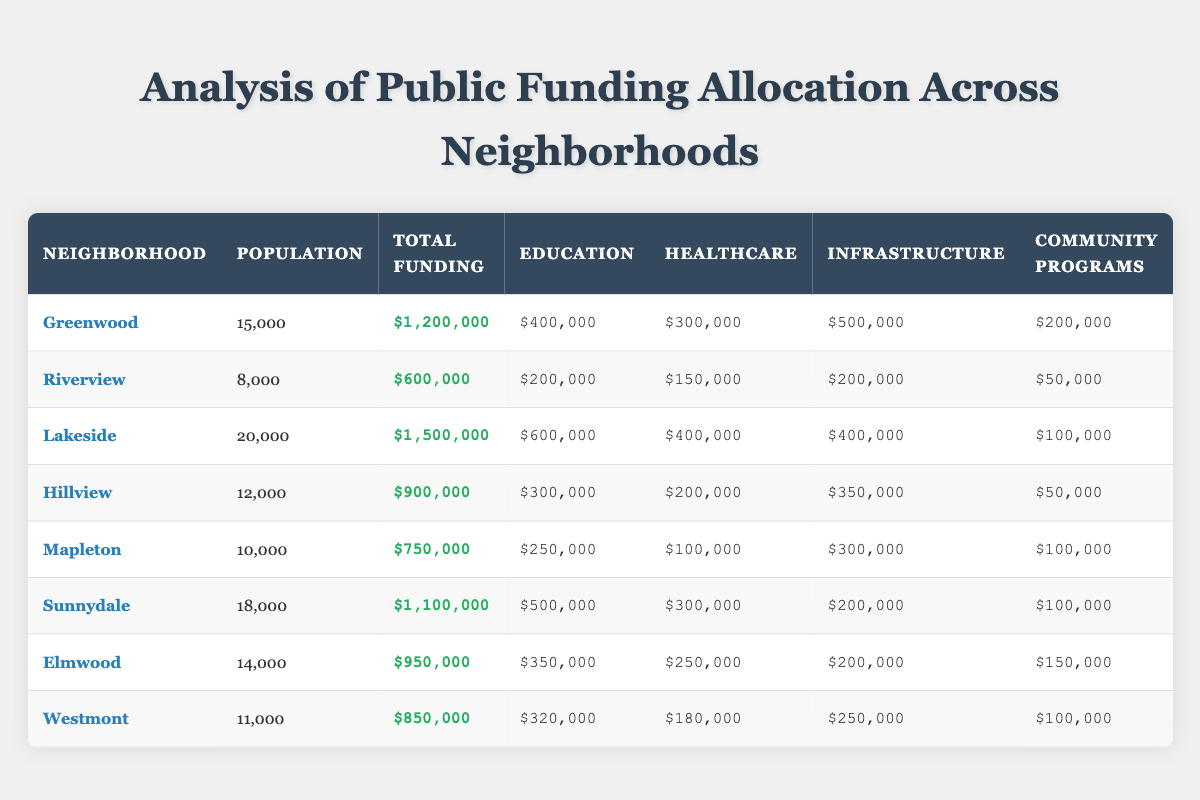What is the total funding allocated to Lakeside? The table shows that Lakeside has a total funding allocated of $1,500,000, which can be found directly in the "Total Funding" column for that neighborhood.
Answer: $1,500,000 Which neighborhood received the most funding for community programs? By examining the "Community Programs" column for each neighborhood, the highest value is $200,000, allocated to Greenwood.
Answer: Greenwood How much more funding does Greenwood receive compared to Riverview? To determine this, subtract Riverview's total funding ($600,000) from Greenwood's total funding ($1,200,000). The difference is $1,200,000 - $600,000 = $600,000.
Answer: $600,000 What is the average population of all neighborhoods listed? To find the average population, sum the populations of all neighborhoods: 15000 + 8000 + 20000 + 12000 + 10000 + 18000 + 14000 + 11000 = 108000. Then divide by the total number of neighborhoods (8): 108000 / 8 = 13500.
Answer: 13500 Is it true that Elmwood has received more funding for healthcare than Hillview? Comparing the "Healthcare" column, Elmwood received $250,000 and Hillview received $200,000. Since $250,000 is greater than $200,000, the statement is true.
Answer: Yes Which neighborhood has the least total funding, and what is that amount? By reviewing the "Total Funding" column, Riverview shows the lowest total at $600,000, making it the neighborhood with the least funding.
Answer: Riverview, $600,000 How do the healthcare fundings of Lakeside and Sunnydale compare? Lakeside received $400,000 for healthcare while Sunnydale received $300,000. Therefore, Lakeside received more funding for healthcare than Sunnydale.
Answer: Lakeside What is the total infrastructure funding across all neighborhoods? To find this, add the infrastructure funding for every neighborhood: 500000 (Greenwood) + 200000 (Riverview) + 400000 (Lakeside) + 350000 (Hillview) + 300000 (Mapleton) + 200000 (Sunnydale) + 200000 (Elmwood) + 250000 (Westmont) = 2100000.
Answer: $2,100,000 Which neighborhood has a population closest to the average population of the neighborhoods? The average population calculated is 13,500. Elmwood has a population of 14,000, which is closest to this average since it is only 500 above the average.
Answer: Elmwood 